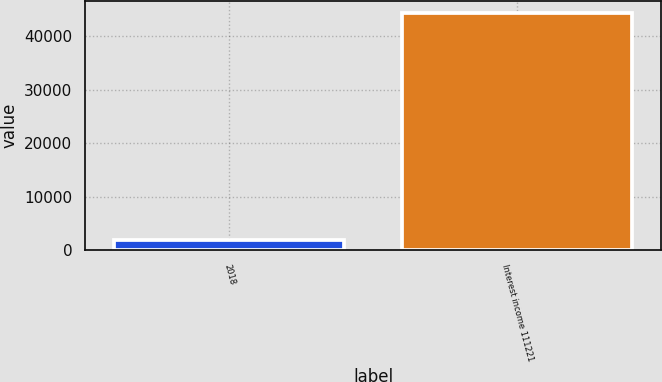<chart> <loc_0><loc_0><loc_500><loc_500><bar_chart><fcel>2018<fcel>Interest income 111221<nl><fcel>2017<fcel>44383<nl></chart> 